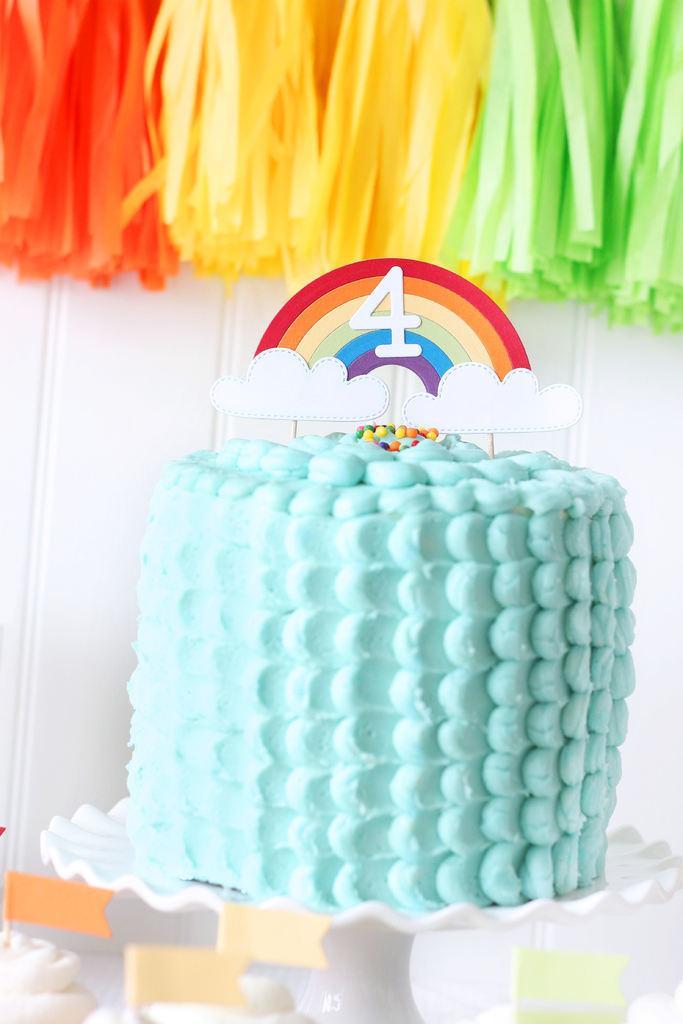Please provide a concise description of this image. At the bottom of the image there is a white plate with a cake on it. And the cake is having blue cream. And on the top of the cake there are toy clouds with rainbow. And on the rainbow there is number four. At the top of the image there are decorative papers in orange, yellow and green color. 